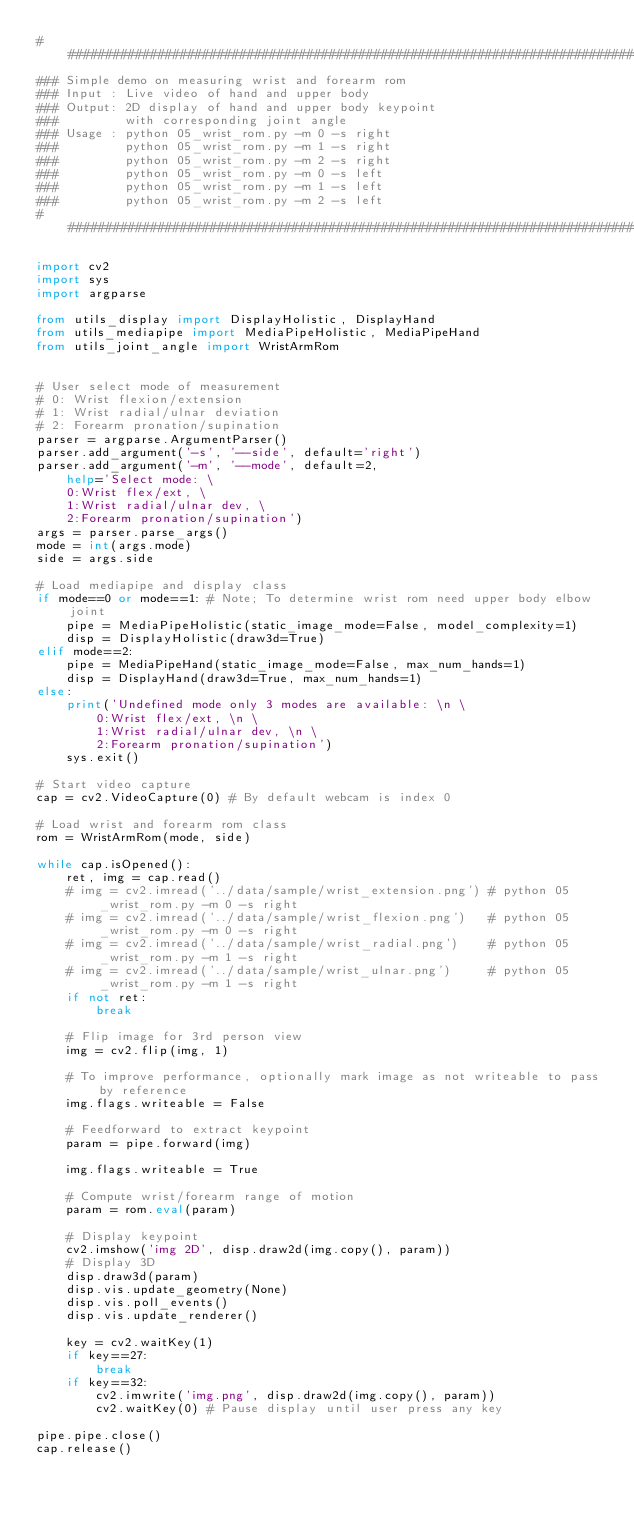Convert code to text. <code><loc_0><loc_0><loc_500><loc_500><_Python_>###############################################################################
### Simple demo on measuring wrist and forearm rom
### Input : Live video of hand and upper body
### Output: 2D display of hand and upper body keypoint 
###         with corresponding joint angle
### Usage : python 05_wrist_rom.py -m 0 -s right
###         python 05_wrist_rom.py -m 1 -s right
###         python 05_wrist_rom.py -m 2 -s right
###         python 05_wrist_rom.py -m 0 -s left
###         python 05_wrist_rom.py -m 1 -s left
###         python 05_wrist_rom.py -m 2 -s left
###############################################################################

import cv2
import sys
import argparse

from utils_display import DisplayHolistic, DisplayHand
from utils_mediapipe import MediaPipeHolistic, MediaPipeHand
from utils_joint_angle import WristArmRom


# User select mode of measurement
# 0: Wrist flexion/extension
# 1: Wrist radial/ulnar deviation
# 2: Forearm pronation/supination
parser = argparse.ArgumentParser()
parser.add_argument('-s', '--side', default='right')
parser.add_argument('-m', '--mode', default=2, 
    help='Select mode: \
    0:Wrist flex/ext, \
    1:Wrist radial/ulnar dev, \
    2:Forearm pronation/supination')
args = parser.parse_args()
mode = int(args.mode)
side = args.side

# Load mediapipe and display class
if mode==0 or mode==1: # Note; To determine wrist rom need upper body elbow joint
    pipe = MediaPipeHolistic(static_image_mode=False, model_complexity=1)
    disp = DisplayHolistic(draw3d=True)
elif mode==2:
    pipe = MediaPipeHand(static_image_mode=False, max_num_hands=1)
    disp = DisplayHand(draw3d=True, max_num_hands=1)
else:
    print('Undefined mode only 3 modes are available: \n \
        0:Wrist flex/ext, \n \
        1:Wrist radial/ulnar dev, \n \
        2:Forearm pronation/supination')
    sys.exit()

# Start video capture
cap = cv2.VideoCapture(0) # By default webcam is index 0

# Load wrist and forearm rom class
rom = WristArmRom(mode, side)

while cap.isOpened():
    ret, img = cap.read()
    # img = cv2.imread('../data/sample/wrist_extension.png') # python 05_wrist_rom.py -m 0 -s right
    # img = cv2.imread('../data/sample/wrist_flexion.png')   # python 05_wrist_rom.py -m 0 -s right
    # img = cv2.imread('../data/sample/wrist_radial.png')    # python 05_wrist_rom.py -m 1 -s right
    # img = cv2.imread('../data/sample/wrist_ulnar.png')     # python 05_wrist_rom.py -m 1 -s right
    if not ret:
        break

    # Flip image for 3rd person view
    img = cv2.flip(img, 1)

    # To improve performance, optionally mark image as not writeable to pass by reference
    img.flags.writeable = False

    # Feedforward to extract keypoint
    param = pipe.forward(img)

    img.flags.writeable = True

    # Compute wrist/forearm range of motion
    param = rom.eval(param)

    # Display keypoint
    cv2.imshow('img 2D', disp.draw2d(img.copy(), param))
    # Display 3D
    disp.draw3d(param)
    disp.vis.update_geometry(None)
    disp.vis.poll_events()
    disp.vis.update_renderer()    

    key = cv2.waitKey(1)
    if key==27:
        break
    if key==32:
        cv2.imwrite('img.png', disp.draw2d(img.copy(), param))
        cv2.waitKey(0) # Pause display until user press any key

pipe.pipe.close()
cap.release()
</code> 